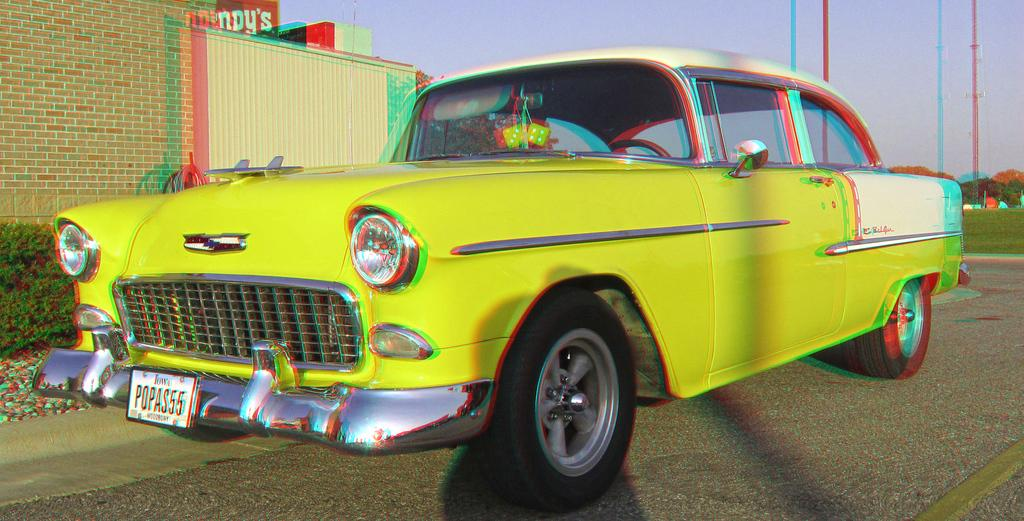<image>
Provide a brief description of the given image. a car with the first three letters of the plate being pop 